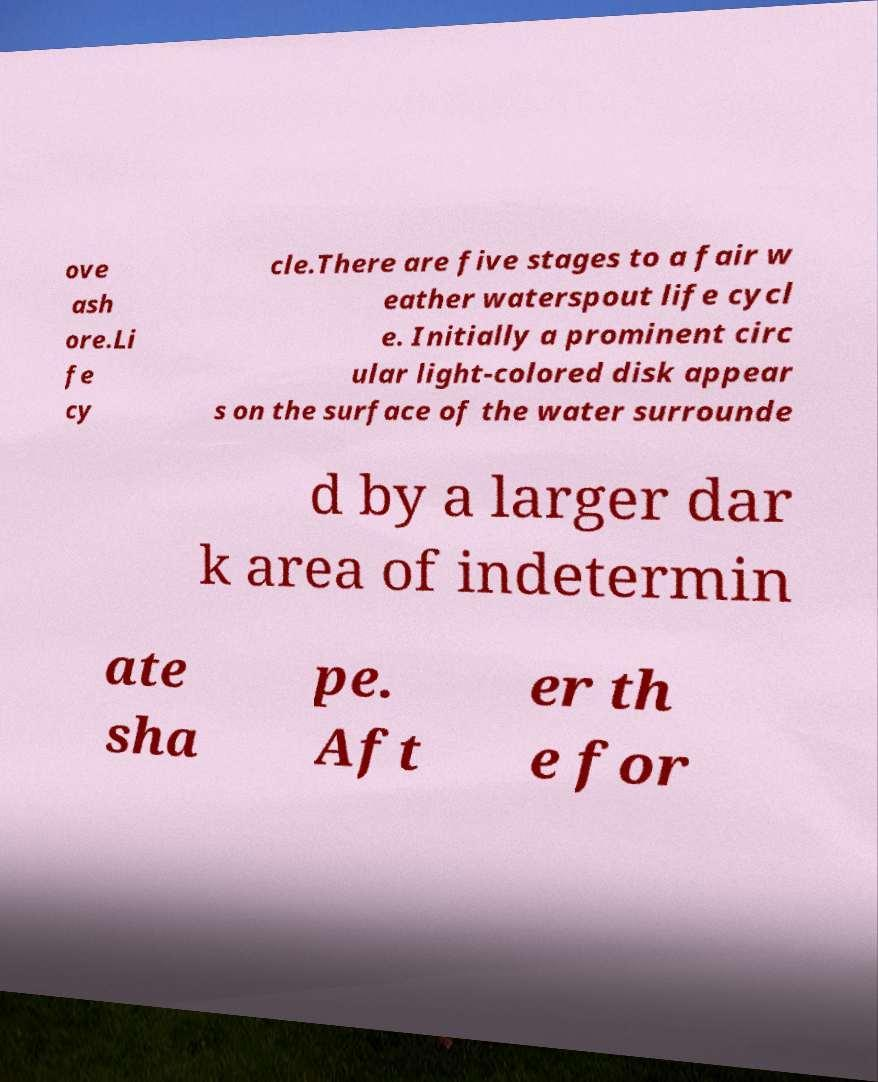I need the written content from this picture converted into text. Can you do that? ove ash ore.Li fe cy cle.There are five stages to a fair w eather waterspout life cycl e. Initially a prominent circ ular light-colored disk appear s on the surface of the water surrounde d by a larger dar k area of indetermin ate sha pe. Aft er th e for 